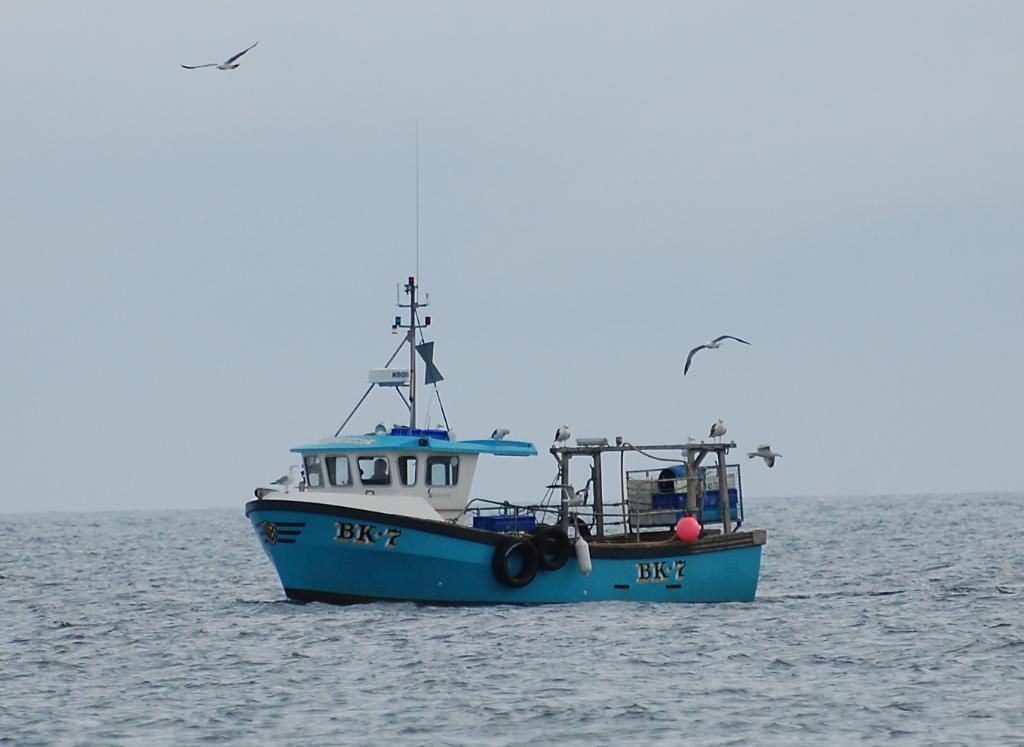What is the main subject of the image? There is a ship in the image. Where is the ship located? The ship is on the water. What else can be seen in the image besides the ship? There are birds flying in the air. What is visible in the background of the image? The sky is visible in the background of the image. What type of dog can be seen swimming alongside the ship in the image? There is no dog present in the image; it only features a ship on the water and birds flying in the air. 